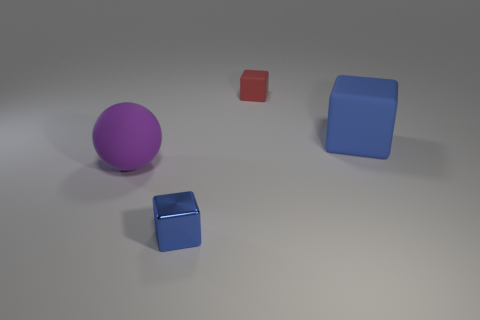How many blue cubes must be subtracted to get 1 blue cubes? 1 Add 4 big matte blocks. How many objects exist? 8 Subtract all cubes. How many objects are left? 1 Add 2 big gray metallic things. How many big gray metallic things exist? 2 Subtract 0 red cylinders. How many objects are left? 4 Subtract all large gray shiny cylinders. Subtract all big balls. How many objects are left? 3 Add 3 big balls. How many big balls are left? 4 